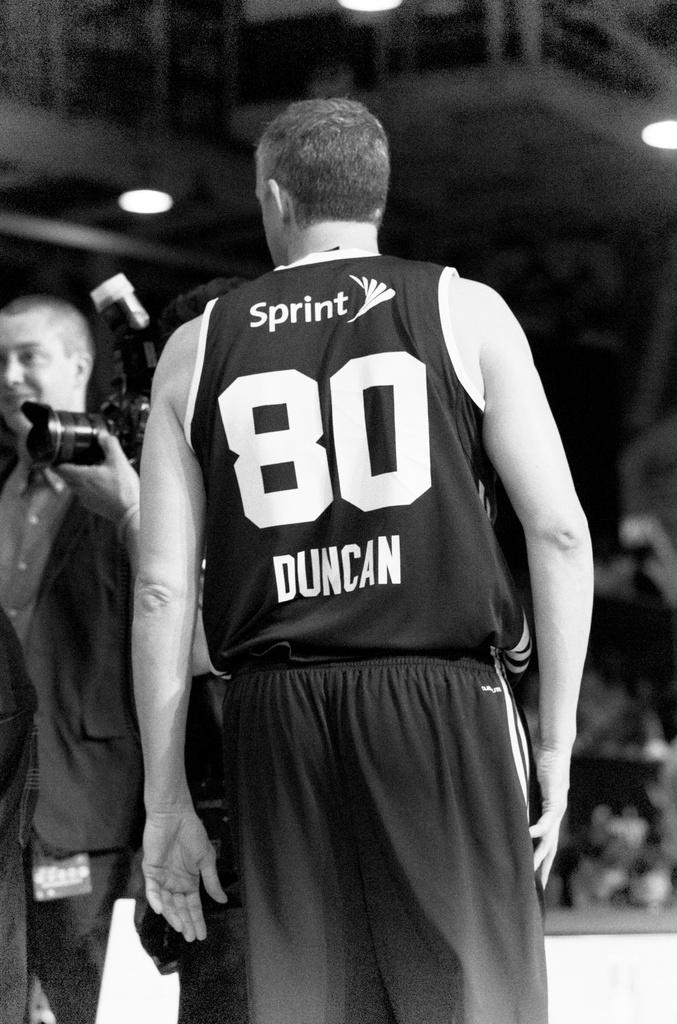Provide a one-sentence caption for the provided image. A basketball player with Sprint 80 Duncan on the back of his shirt. 